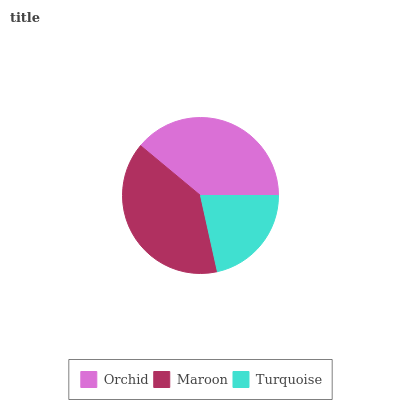Is Turquoise the minimum?
Answer yes or no. Yes. Is Maroon the maximum?
Answer yes or no. Yes. Is Maroon the minimum?
Answer yes or no. No. Is Turquoise the maximum?
Answer yes or no. No. Is Maroon greater than Turquoise?
Answer yes or no. Yes. Is Turquoise less than Maroon?
Answer yes or no. Yes. Is Turquoise greater than Maroon?
Answer yes or no. No. Is Maroon less than Turquoise?
Answer yes or no. No. Is Orchid the high median?
Answer yes or no. Yes. Is Orchid the low median?
Answer yes or no. Yes. Is Maroon the high median?
Answer yes or no. No. Is Turquoise the low median?
Answer yes or no. No. 